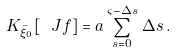Convert formula to latex. <formula><loc_0><loc_0><loc_500><loc_500>K _ { \bar { \xi } _ { 0 } } [ \ J f ] = a \sum _ { s = 0 } ^ { \varsigma - \Delta s } \, \Delta s \, .</formula> 